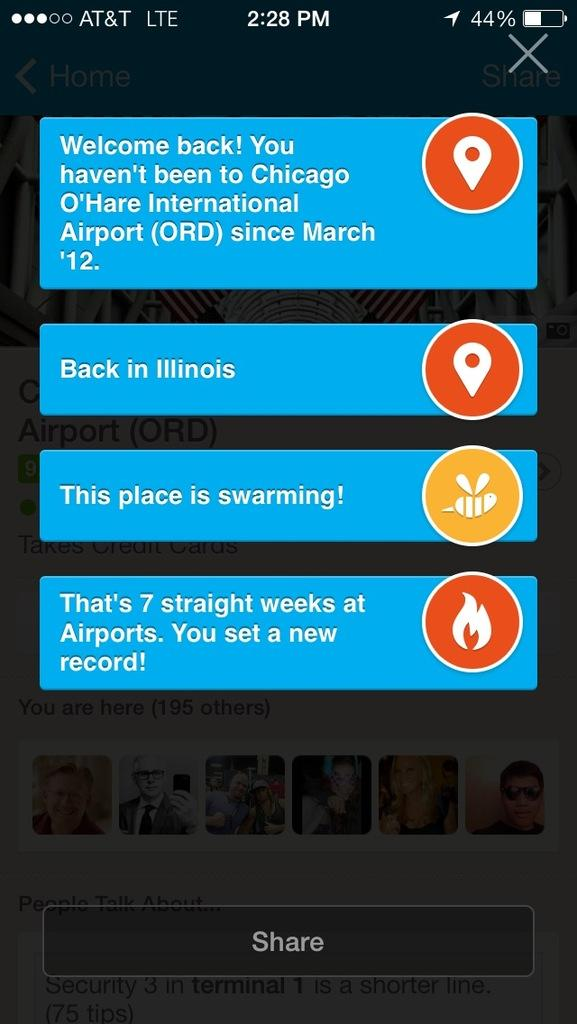<image>
Provide a brief description of the given image. A smartphone display screen with the displaying messages and a button on the bottom saying Share 